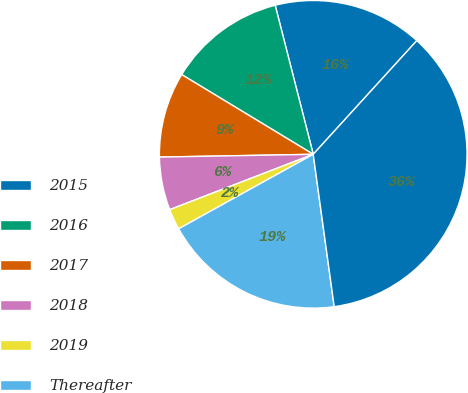<chart> <loc_0><loc_0><loc_500><loc_500><pie_chart><fcel>2015<fcel>2016<fcel>2017<fcel>2018<fcel>2019<fcel>Thereafter<fcel>Total<nl><fcel>15.74%<fcel>12.35%<fcel>8.96%<fcel>5.57%<fcel>2.19%<fcel>19.13%<fcel>36.06%<nl></chart> 